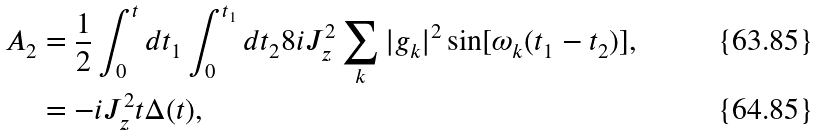<formula> <loc_0><loc_0><loc_500><loc_500>A _ { 2 } & = \frac { 1 } { 2 } \int _ { 0 } ^ { t } d t _ { 1 } \int _ { 0 } ^ { t _ { 1 } } d t _ { 2 } 8 i J _ { z } ^ { 2 } \sum _ { k } | g _ { k } | ^ { 2 } \sin [ \omega _ { k } ( t _ { 1 } - t _ { 2 } ) ] , \\ & = - i J _ { z } ^ { 2 } t \Delta ( t ) ,</formula> 